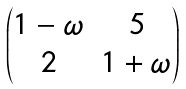Convert formula to latex. <formula><loc_0><loc_0><loc_500><loc_500>\begin{pmatrix} 1 - \omega & 5 \\ 2 & 1 + \omega \end{pmatrix}</formula> 